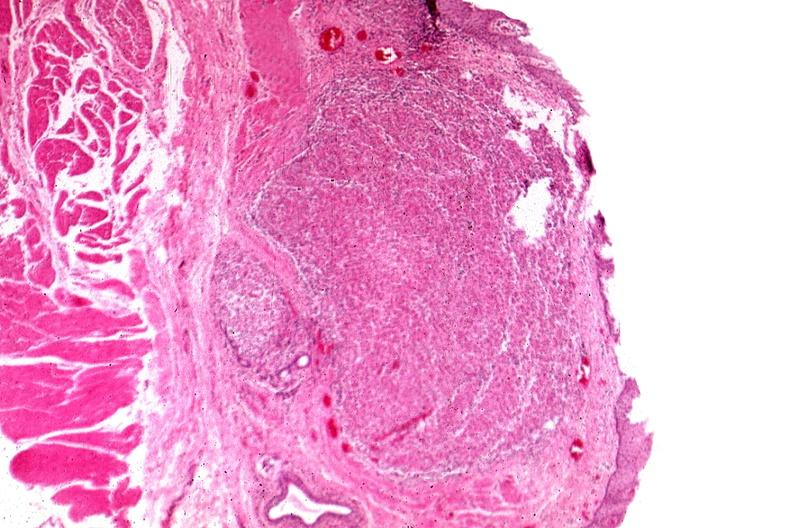s sarcoidosis present?
Answer the question using a single word or phrase. Yes 